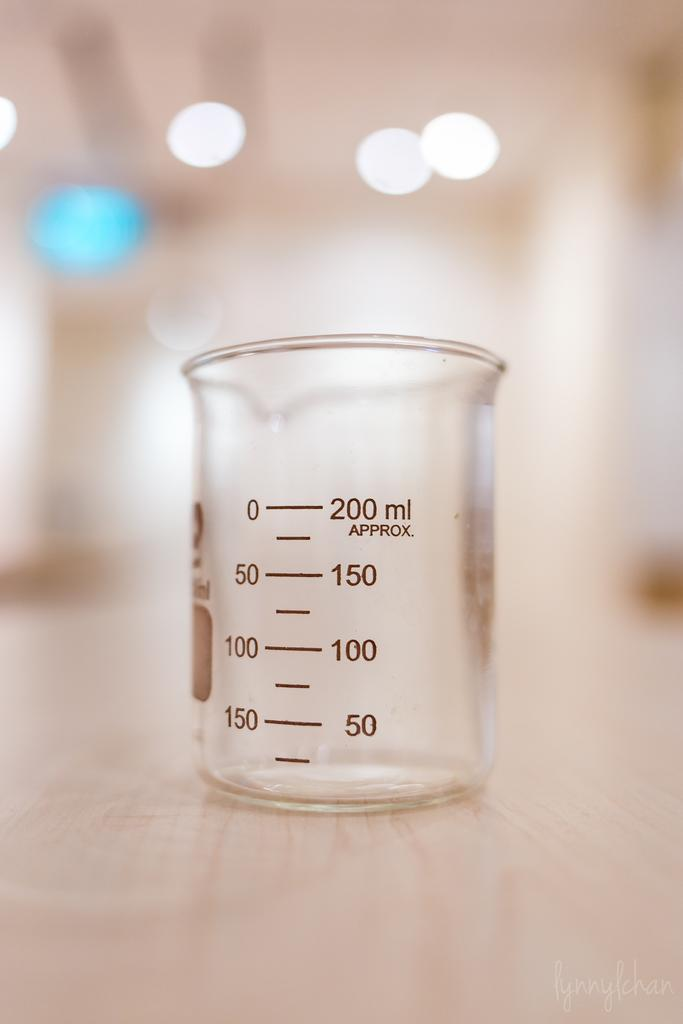Provide a one-sentence caption for the provided image. The measuring cup holds up to 200 ml of liquid. 